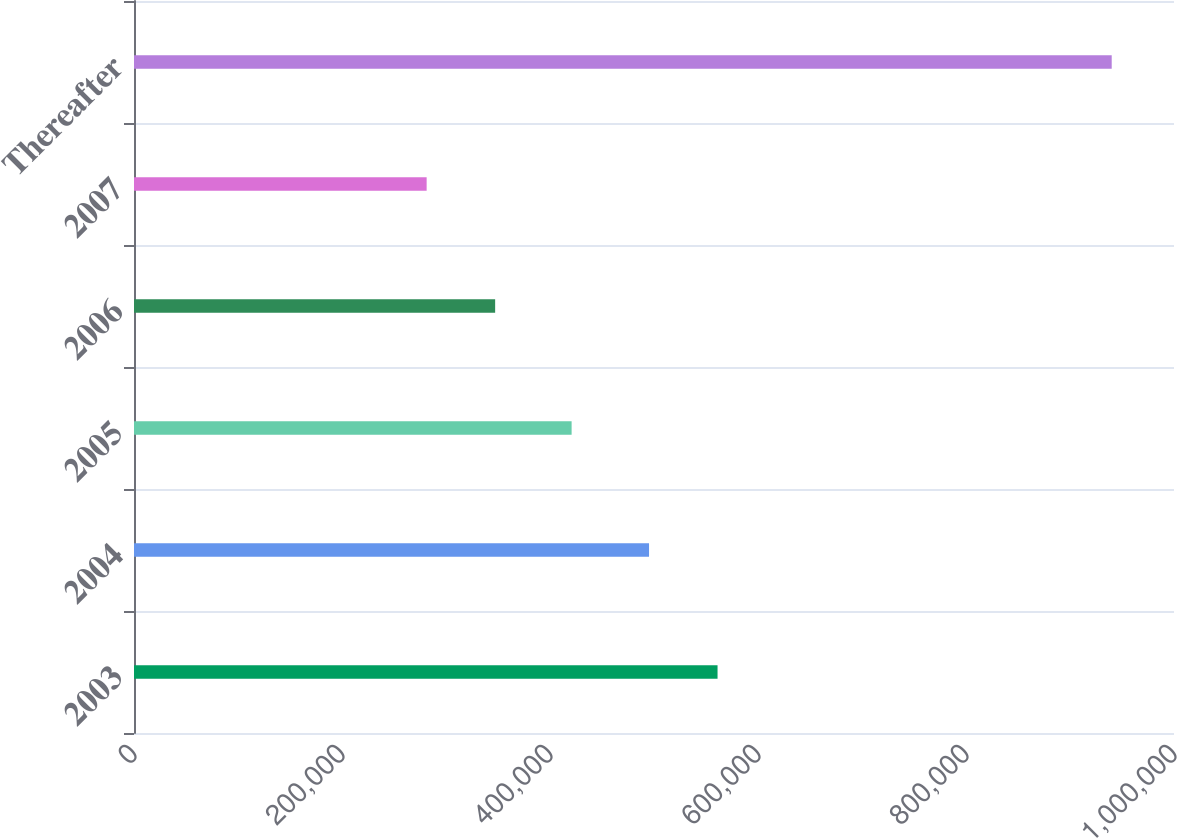Convert chart. <chart><loc_0><loc_0><loc_500><loc_500><bar_chart><fcel>2003<fcel>2004<fcel>2005<fcel>2006<fcel>2007<fcel>Thereafter<nl><fcel>561101<fcel>495229<fcel>420784<fcel>347258<fcel>281386<fcel>940103<nl></chart> 